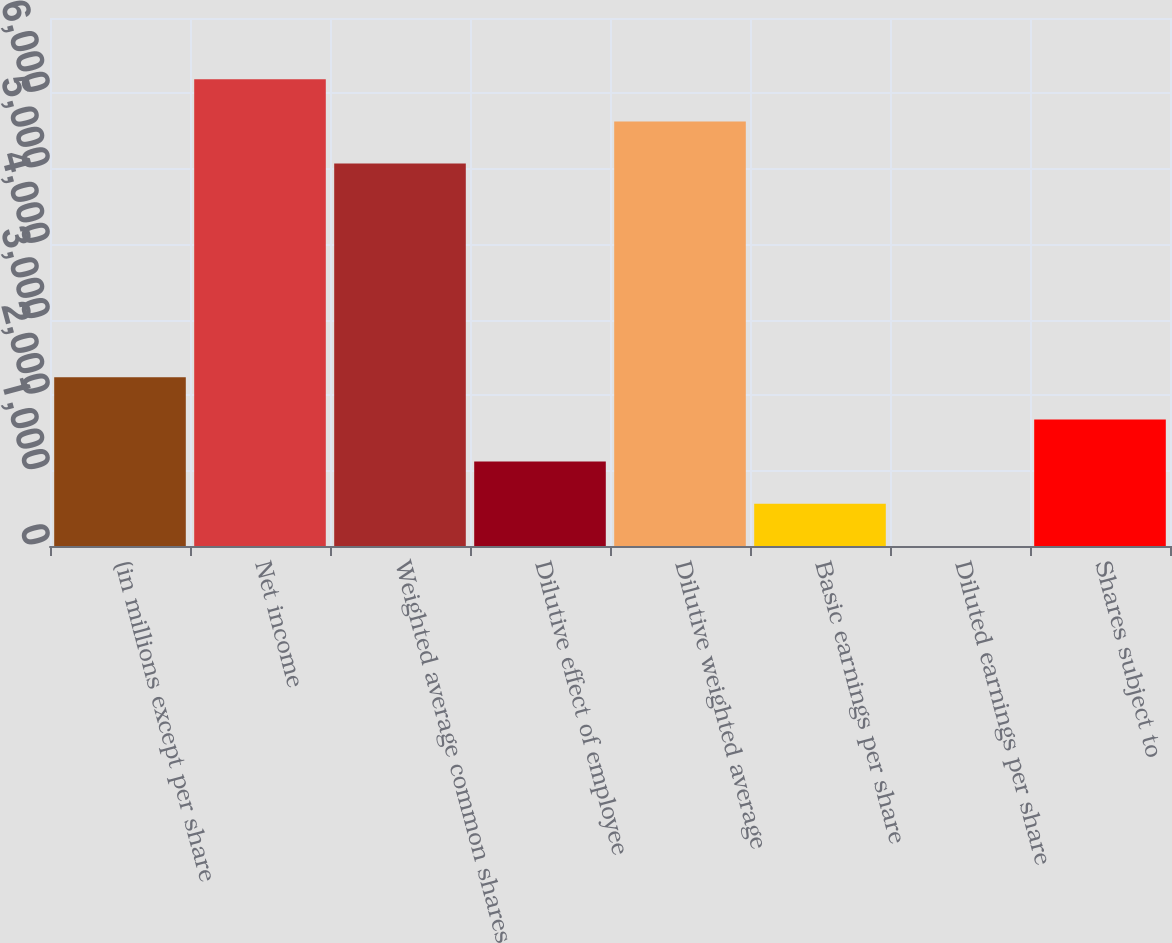Convert chart to OTSL. <chart><loc_0><loc_0><loc_500><loc_500><bar_chart><fcel>(in millions except per share<fcel>Net income<fcel>Weighted average common shares<fcel>Dilutive effect of employee<fcel>Dilutive weighted average<fcel>Basic earnings per share<fcel>Diluted earnings per share<fcel>Shares subject to<nl><fcel>2237.85<fcel>6188.38<fcel>5070<fcel>1119.47<fcel>5629.19<fcel>560.28<fcel>1.09<fcel>1678.66<nl></chart> 